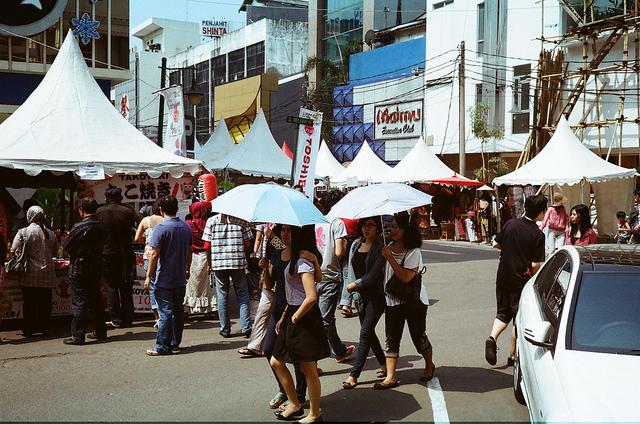How many awnings?
Be succinct. 7. What color is the parked car?
Give a very brief answer. White. Could seven people walk under each umbrella?
Quick response, please. No. 